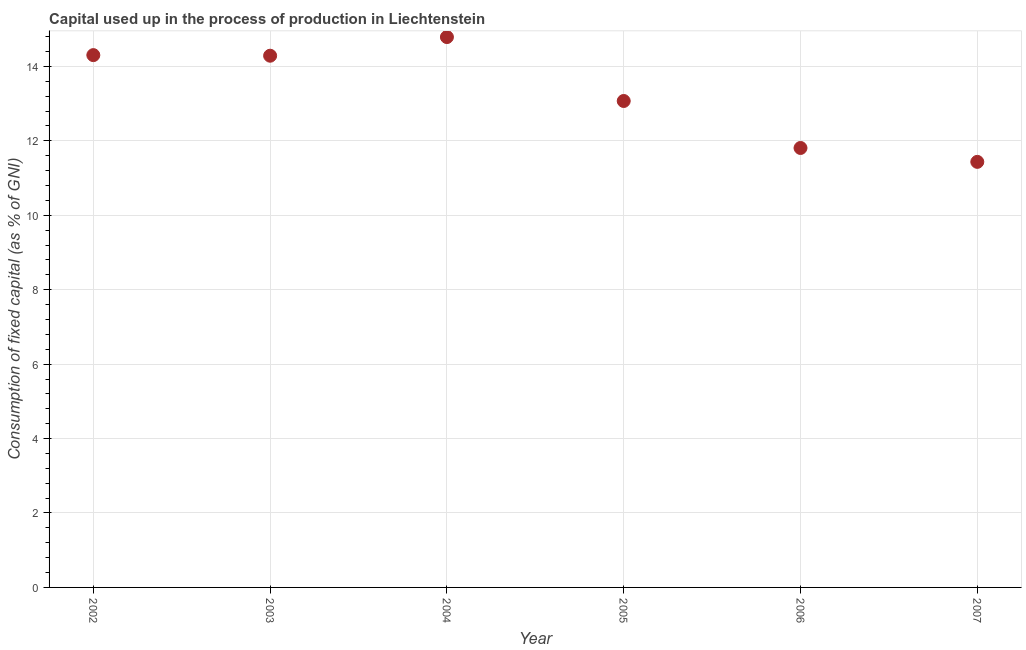What is the consumption of fixed capital in 2002?
Your answer should be compact. 14.3. Across all years, what is the maximum consumption of fixed capital?
Give a very brief answer. 14.79. Across all years, what is the minimum consumption of fixed capital?
Your answer should be compact. 11.44. In which year was the consumption of fixed capital minimum?
Keep it short and to the point. 2007. What is the sum of the consumption of fixed capital?
Keep it short and to the point. 79.69. What is the difference between the consumption of fixed capital in 2003 and 2007?
Keep it short and to the point. 2.85. What is the average consumption of fixed capital per year?
Make the answer very short. 13.28. What is the median consumption of fixed capital?
Make the answer very short. 13.68. Do a majority of the years between 2007 and 2005 (inclusive) have consumption of fixed capital greater than 12 %?
Make the answer very short. No. What is the ratio of the consumption of fixed capital in 2002 to that in 2007?
Keep it short and to the point. 1.25. Is the consumption of fixed capital in 2005 less than that in 2007?
Offer a very short reply. No. What is the difference between the highest and the second highest consumption of fixed capital?
Offer a very short reply. 0.49. What is the difference between the highest and the lowest consumption of fixed capital?
Ensure brevity in your answer.  3.35. What is the title of the graph?
Provide a short and direct response. Capital used up in the process of production in Liechtenstein. What is the label or title of the X-axis?
Give a very brief answer. Year. What is the label or title of the Y-axis?
Your response must be concise. Consumption of fixed capital (as % of GNI). What is the Consumption of fixed capital (as % of GNI) in 2002?
Your answer should be very brief. 14.3. What is the Consumption of fixed capital (as % of GNI) in 2003?
Provide a short and direct response. 14.29. What is the Consumption of fixed capital (as % of GNI) in 2004?
Offer a very short reply. 14.79. What is the Consumption of fixed capital (as % of GNI) in 2005?
Your answer should be compact. 13.07. What is the Consumption of fixed capital (as % of GNI) in 2006?
Your answer should be very brief. 11.81. What is the Consumption of fixed capital (as % of GNI) in 2007?
Offer a very short reply. 11.44. What is the difference between the Consumption of fixed capital (as % of GNI) in 2002 and 2003?
Offer a very short reply. 0.02. What is the difference between the Consumption of fixed capital (as % of GNI) in 2002 and 2004?
Ensure brevity in your answer.  -0.49. What is the difference between the Consumption of fixed capital (as % of GNI) in 2002 and 2005?
Provide a succinct answer. 1.23. What is the difference between the Consumption of fixed capital (as % of GNI) in 2002 and 2006?
Your answer should be very brief. 2.5. What is the difference between the Consumption of fixed capital (as % of GNI) in 2002 and 2007?
Your answer should be very brief. 2.87. What is the difference between the Consumption of fixed capital (as % of GNI) in 2003 and 2004?
Make the answer very short. -0.5. What is the difference between the Consumption of fixed capital (as % of GNI) in 2003 and 2005?
Keep it short and to the point. 1.22. What is the difference between the Consumption of fixed capital (as % of GNI) in 2003 and 2006?
Give a very brief answer. 2.48. What is the difference between the Consumption of fixed capital (as % of GNI) in 2003 and 2007?
Offer a very short reply. 2.85. What is the difference between the Consumption of fixed capital (as % of GNI) in 2004 and 2005?
Your response must be concise. 1.72. What is the difference between the Consumption of fixed capital (as % of GNI) in 2004 and 2006?
Offer a very short reply. 2.98. What is the difference between the Consumption of fixed capital (as % of GNI) in 2004 and 2007?
Offer a terse response. 3.35. What is the difference between the Consumption of fixed capital (as % of GNI) in 2005 and 2006?
Your answer should be very brief. 1.26. What is the difference between the Consumption of fixed capital (as % of GNI) in 2005 and 2007?
Give a very brief answer. 1.64. What is the difference between the Consumption of fixed capital (as % of GNI) in 2006 and 2007?
Offer a very short reply. 0.37. What is the ratio of the Consumption of fixed capital (as % of GNI) in 2002 to that in 2005?
Your response must be concise. 1.09. What is the ratio of the Consumption of fixed capital (as % of GNI) in 2002 to that in 2006?
Ensure brevity in your answer.  1.21. What is the ratio of the Consumption of fixed capital (as % of GNI) in 2002 to that in 2007?
Give a very brief answer. 1.25. What is the ratio of the Consumption of fixed capital (as % of GNI) in 2003 to that in 2005?
Your response must be concise. 1.09. What is the ratio of the Consumption of fixed capital (as % of GNI) in 2003 to that in 2006?
Your answer should be very brief. 1.21. What is the ratio of the Consumption of fixed capital (as % of GNI) in 2003 to that in 2007?
Offer a very short reply. 1.25. What is the ratio of the Consumption of fixed capital (as % of GNI) in 2004 to that in 2005?
Ensure brevity in your answer.  1.13. What is the ratio of the Consumption of fixed capital (as % of GNI) in 2004 to that in 2006?
Ensure brevity in your answer.  1.25. What is the ratio of the Consumption of fixed capital (as % of GNI) in 2004 to that in 2007?
Offer a very short reply. 1.29. What is the ratio of the Consumption of fixed capital (as % of GNI) in 2005 to that in 2006?
Keep it short and to the point. 1.11. What is the ratio of the Consumption of fixed capital (as % of GNI) in 2005 to that in 2007?
Provide a succinct answer. 1.14. What is the ratio of the Consumption of fixed capital (as % of GNI) in 2006 to that in 2007?
Your answer should be compact. 1.03. 